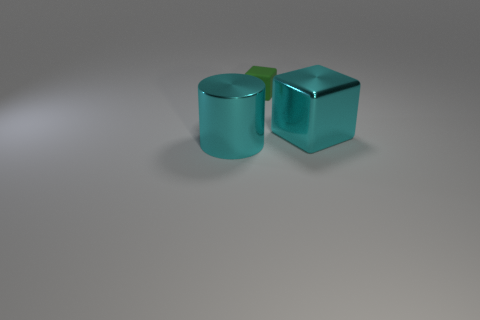What is the texture of the surface on which the objects are placed? The surface appears smooth and possibly of a matte finish, reflecting some light but not as much as a glossy surface would. It presents as a neutral tone which suggests it may be designed not to detract attention from the objects. 